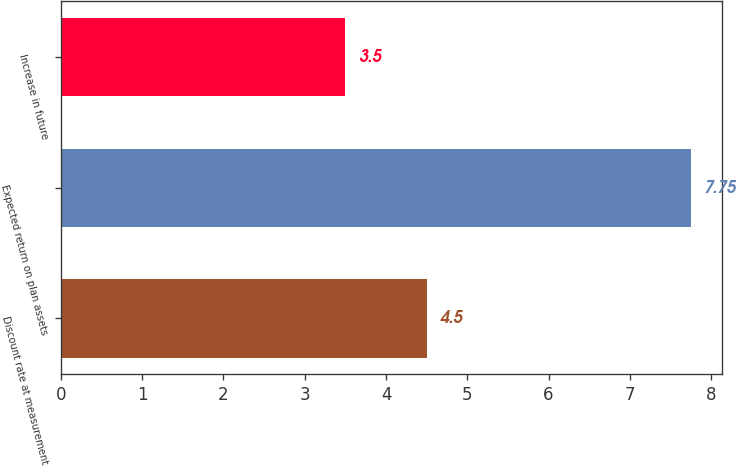<chart> <loc_0><loc_0><loc_500><loc_500><bar_chart><fcel>Discount rate at measurement<fcel>Expected return on plan assets<fcel>Increase in future<nl><fcel>4.5<fcel>7.75<fcel>3.5<nl></chart> 